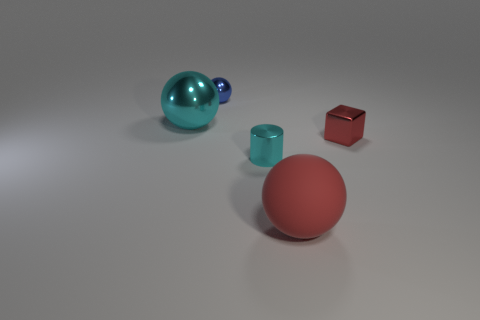Subtract all shiny spheres. How many spheres are left? 1 Subtract all small yellow cylinders. Subtract all rubber balls. How many objects are left? 4 Add 3 blocks. How many blocks are left? 4 Add 4 large gray balls. How many large gray balls exist? 4 Add 1 tiny metal balls. How many objects exist? 6 Subtract all blue balls. How many balls are left? 2 Subtract 1 cyan spheres. How many objects are left? 4 Subtract all cylinders. How many objects are left? 4 Subtract all yellow cylinders. Subtract all red balls. How many cylinders are left? 1 Subtract all cyan cylinders. How many brown blocks are left? 0 